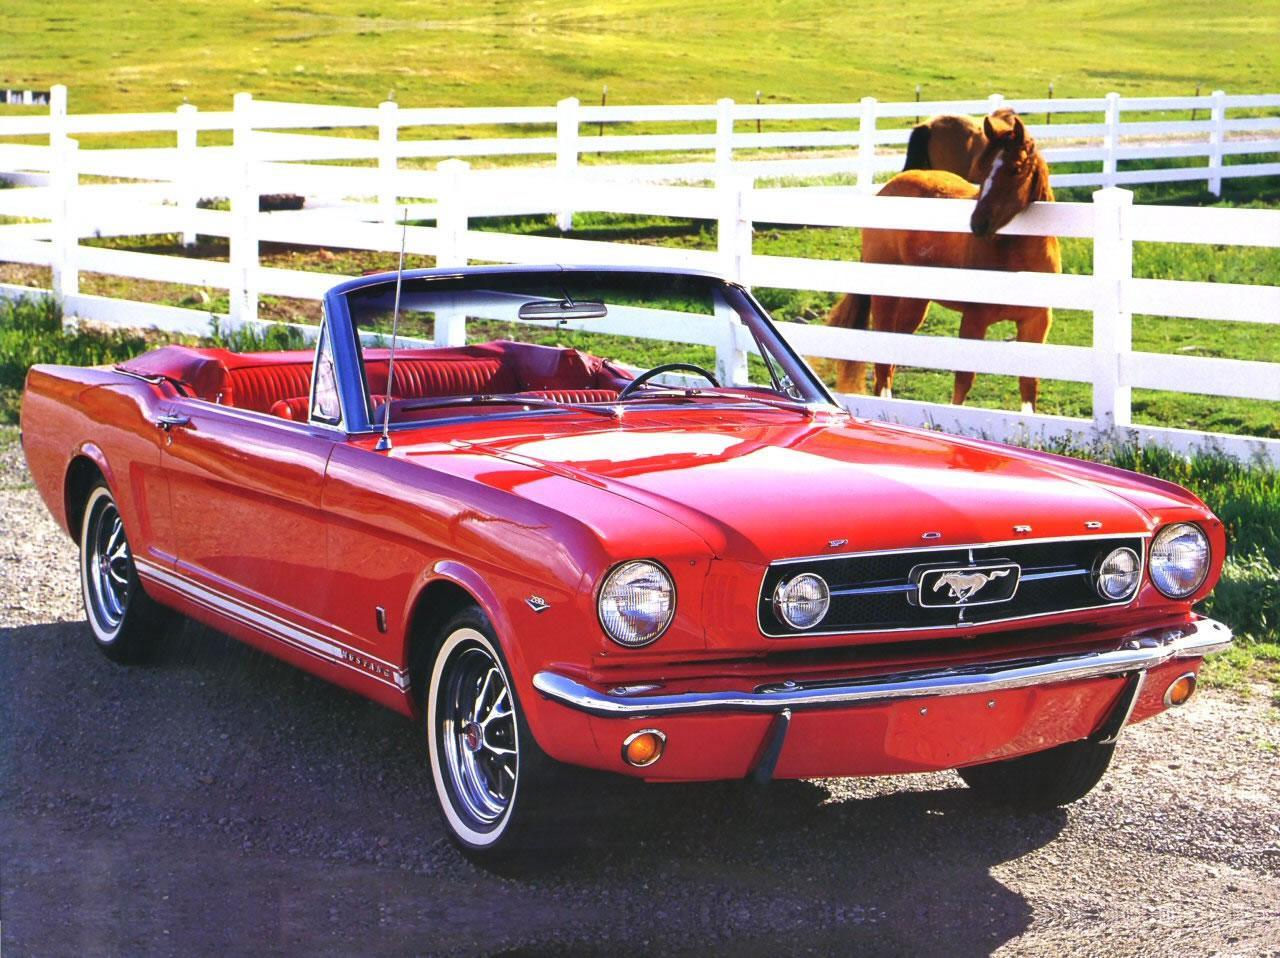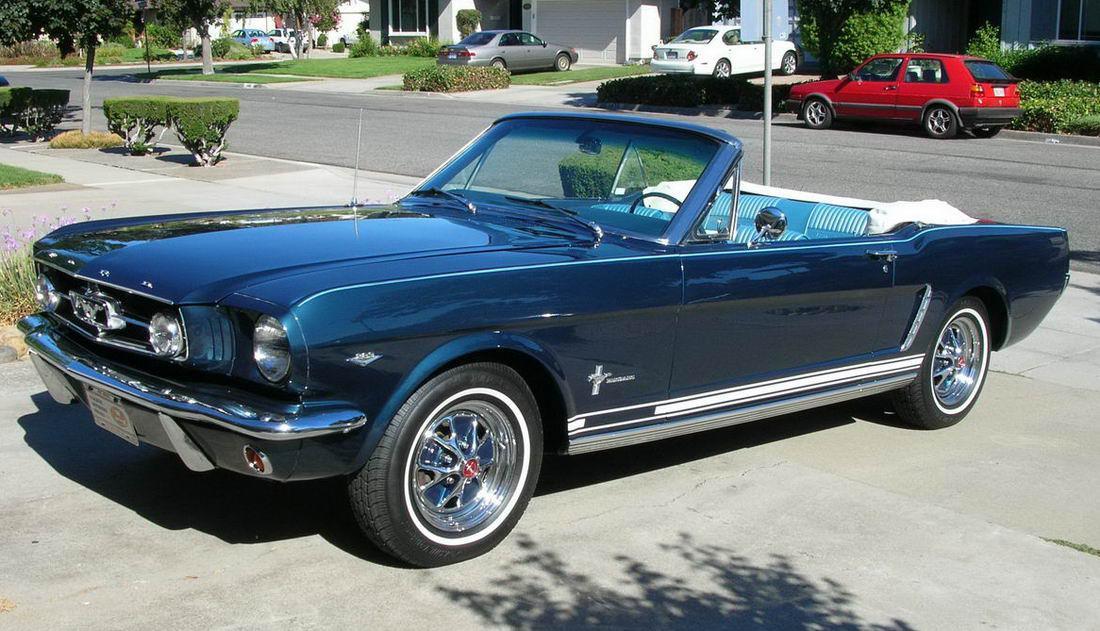The first image is the image on the left, the second image is the image on the right. Considering the images on both sides, is "There is a car whose main body color is red." valid? Answer yes or no. Yes. The first image is the image on the left, the second image is the image on the right. Given the left and right images, does the statement "One of the images has a red Ford Mustang convertible." hold true? Answer yes or no. Yes. 